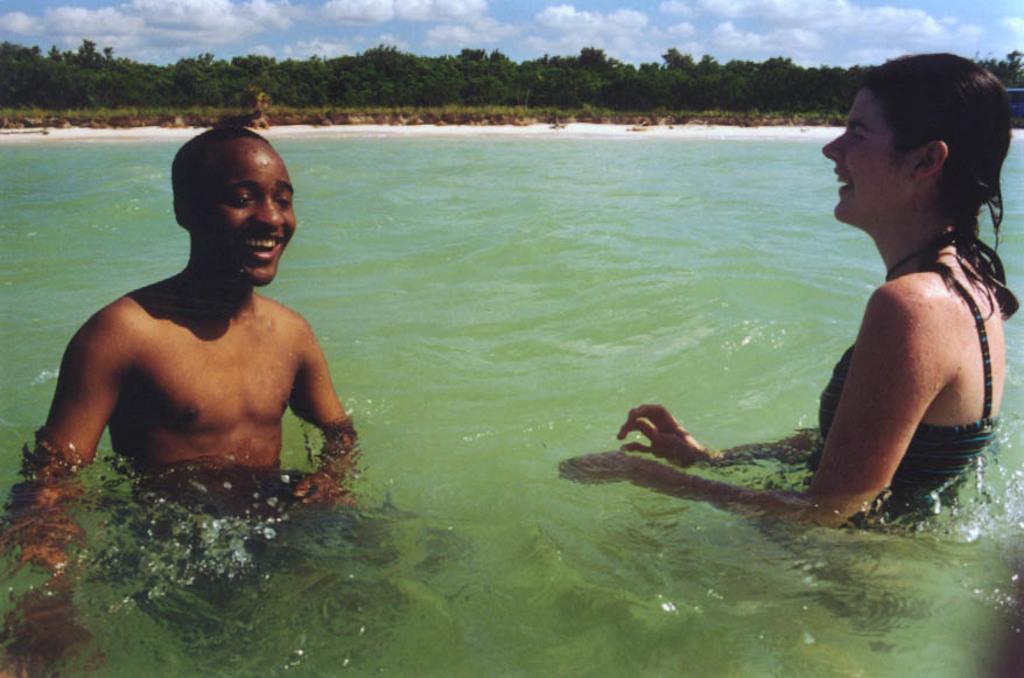Can you describe this image briefly? In this picture I can observe two members in the water. One of them is a man. The man is smiling. He is on the left side and the other one is a woman. She is smiling. She is on the right side. In the background there are trees and there are clouds in the sky. 